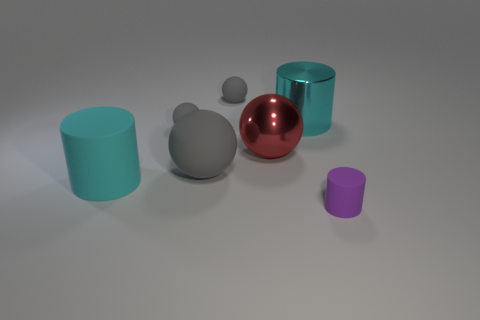Is there anything else of the same color as the metallic ball?
Your answer should be compact. No. Are there fewer big rubber spheres on the right side of the red ball than small purple matte cylinders that are in front of the purple cylinder?
Your answer should be very brief. No. How big is the matte sphere that is in front of the large metallic cylinder and behind the large gray ball?
Provide a short and direct response. Small. There is a big matte thing that is behind the matte cylinder that is behind the purple matte cylinder; is there a cyan matte cylinder that is in front of it?
Make the answer very short. Yes. Are there any yellow shiny cylinders?
Provide a succinct answer. No. Is the number of big cyan objects behind the big gray thing greater than the number of purple rubber objects that are left of the tiny cylinder?
Your answer should be very brief. Yes. There is a purple cylinder that is made of the same material as the large gray object; what is its size?
Ensure brevity in your answer.  Small. How big is the cyan thing in front of the big cyan cylinder behind the rubber cylinder that is behind the purple matte object?
Offer a very short reply. Large. There is a metallic thing behind the red shiny object; what is its color?
Give a very brief answer. Cyan. Is the number of gray things that are behind the cyan shiny object greater than the number of small cyan cylinders?
Make the answer very short. Yes. 